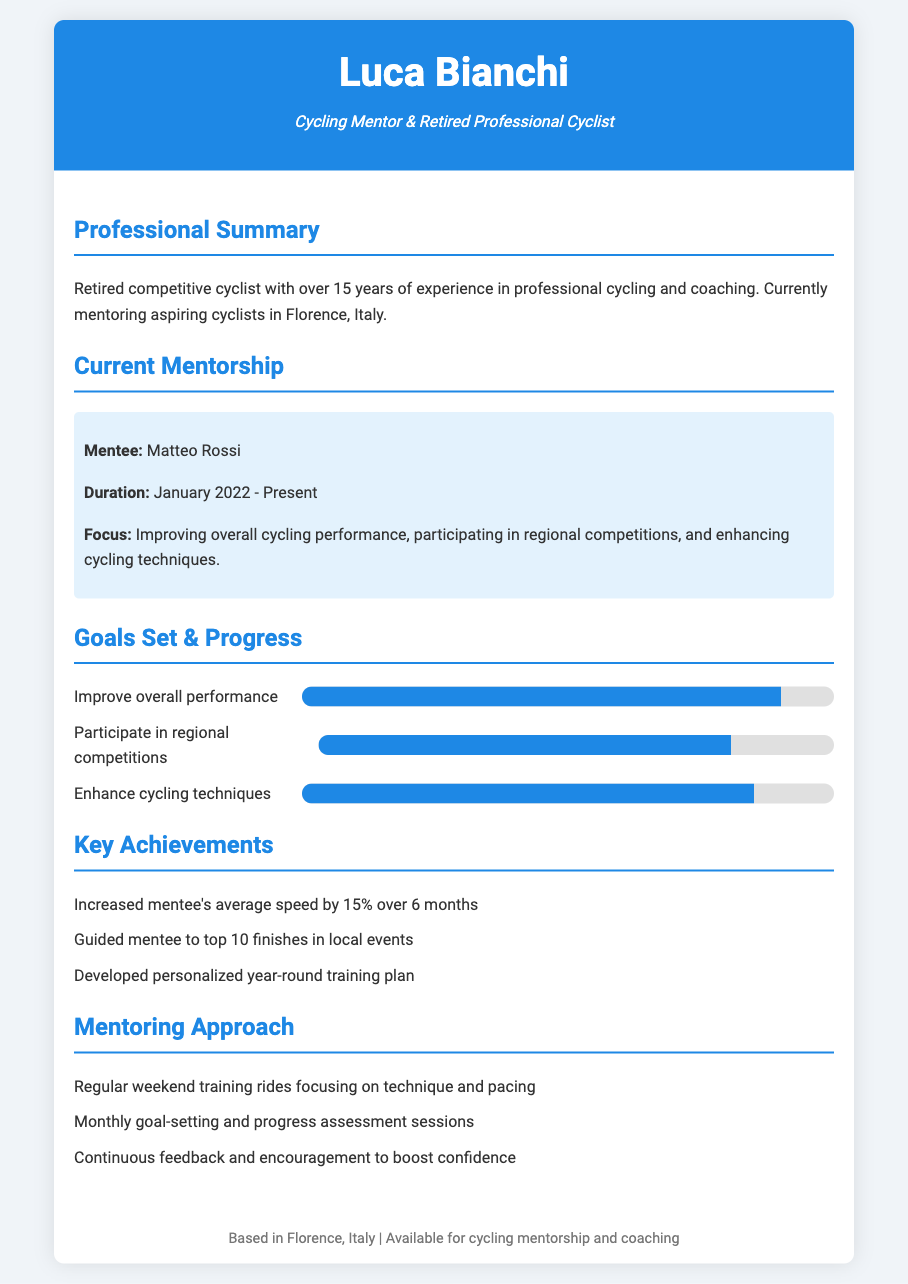What is the name of the mentee? The document specifically mentions the mentee's name as Matteo Rossi.
Answer: Matteo Rossi What is the duration of the mentorship? The document states the mentorship duration as from January 2022 to Present.
Answer: January 2022 - Present What is the percentage progress achieved in improving overall performance? The document indicates that there has been a 90% progress in overall performance improvement.
Answer: 90% How much has Matteo's average speed increased? According to the key achievements, Matteo's average speed increased by 15% over 6 months.
Answer: 15% What is one key aspect of Luca Bianchi's mentoring approach? The document lists regular weekend training rides as one of the key aspects of the mentoring approach.
Answer: Regular weekend training rides How many goals are currently set for Matteo? The document outlines three main goals set for Matteo: improving performance, participating in competitions, and enhancing techniques.
Answer: Three What is the main focus of the current mentorship? The document states that the mentorship focuses on improving overall cycling performance, participating in competitions, and enhancing techniques.
Answer: Improving overall cycling performance What color is the header background? The document specifies that the header background color is #1e88e5, which is a shade of blue.
Answer: Blue How many local events did Matteo achieve top 10 finishes in? The key achievements section indicates he had top 10 finishes in local events, but does not specify the exact number.
Answer: Not specified 